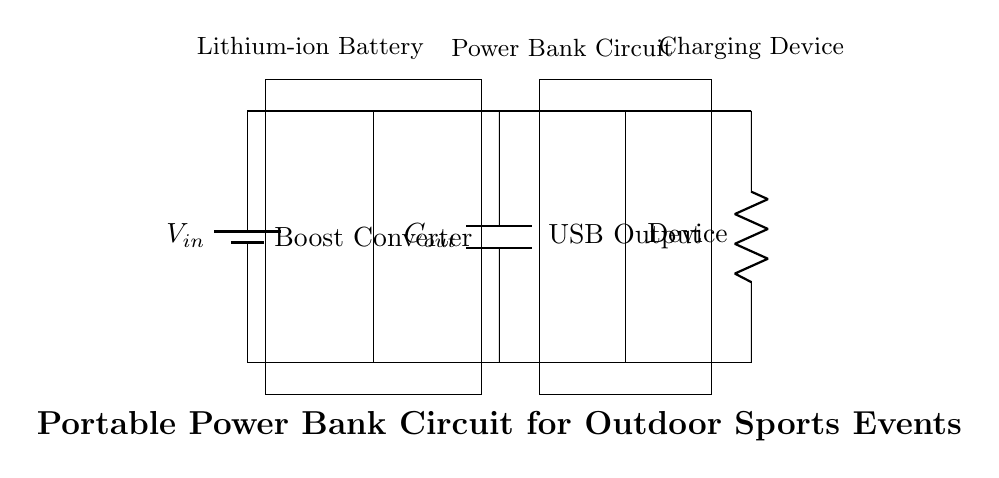What is the input voltage in this circuit? The input voltage is indicated by the label "V_in" on the battery component. This label denotes the voltage supplied by the lithium-ion battery in the circuit.
Answer: V_in What component increases the voltage in this circuit? The boost converter is labeled in the diagram and is used to step up (increase) the voltage supplied by the input source, which is the battery.
Answer: Boost Converter What type of output does this circuit provide? The circuit has a USB output, which is shown in the diagram with the label "USB Output". This denotes the type of output connection available for charging devices.
Answer: USB Output How many capacitors are present in this circuit? The circuit has one output capacitor labeled "C_out", which is used to smooth the output voltage provided to the charging device.
Answer: One Which element represents the load in the circuit? The load in this circuit is represented by a resistor labeled "Device", indicating that this is the component being powered or charged.
Answer: Device What is the primary purpose of the boost converter in this circuit? The primary purpose of the boost converter is to increase the voltage from the lithium-ion battery to a level suitable for charging devices through the USB output.
Answer: Increase voltage If the battery voltage is 3.7 volts, what would the output voltage likely be after the boost converter? The output voltage from the boost converter would typically be higher than the battery voltage, often around 5 volts for USB charging, depending on the circuit design.
Answer: Approximately 5 volts 